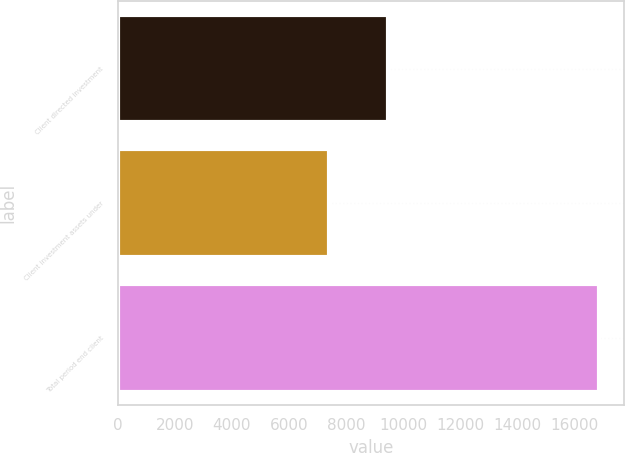<chart> <loc_0><loc_0><loc_500><loc_500><bar_chart><fcel>Client directed investment<fcel>Client investment assets under<fcel>Total period end client<nl><fcel>9479<fcel>7415<fcel>16894<nl></chart> 